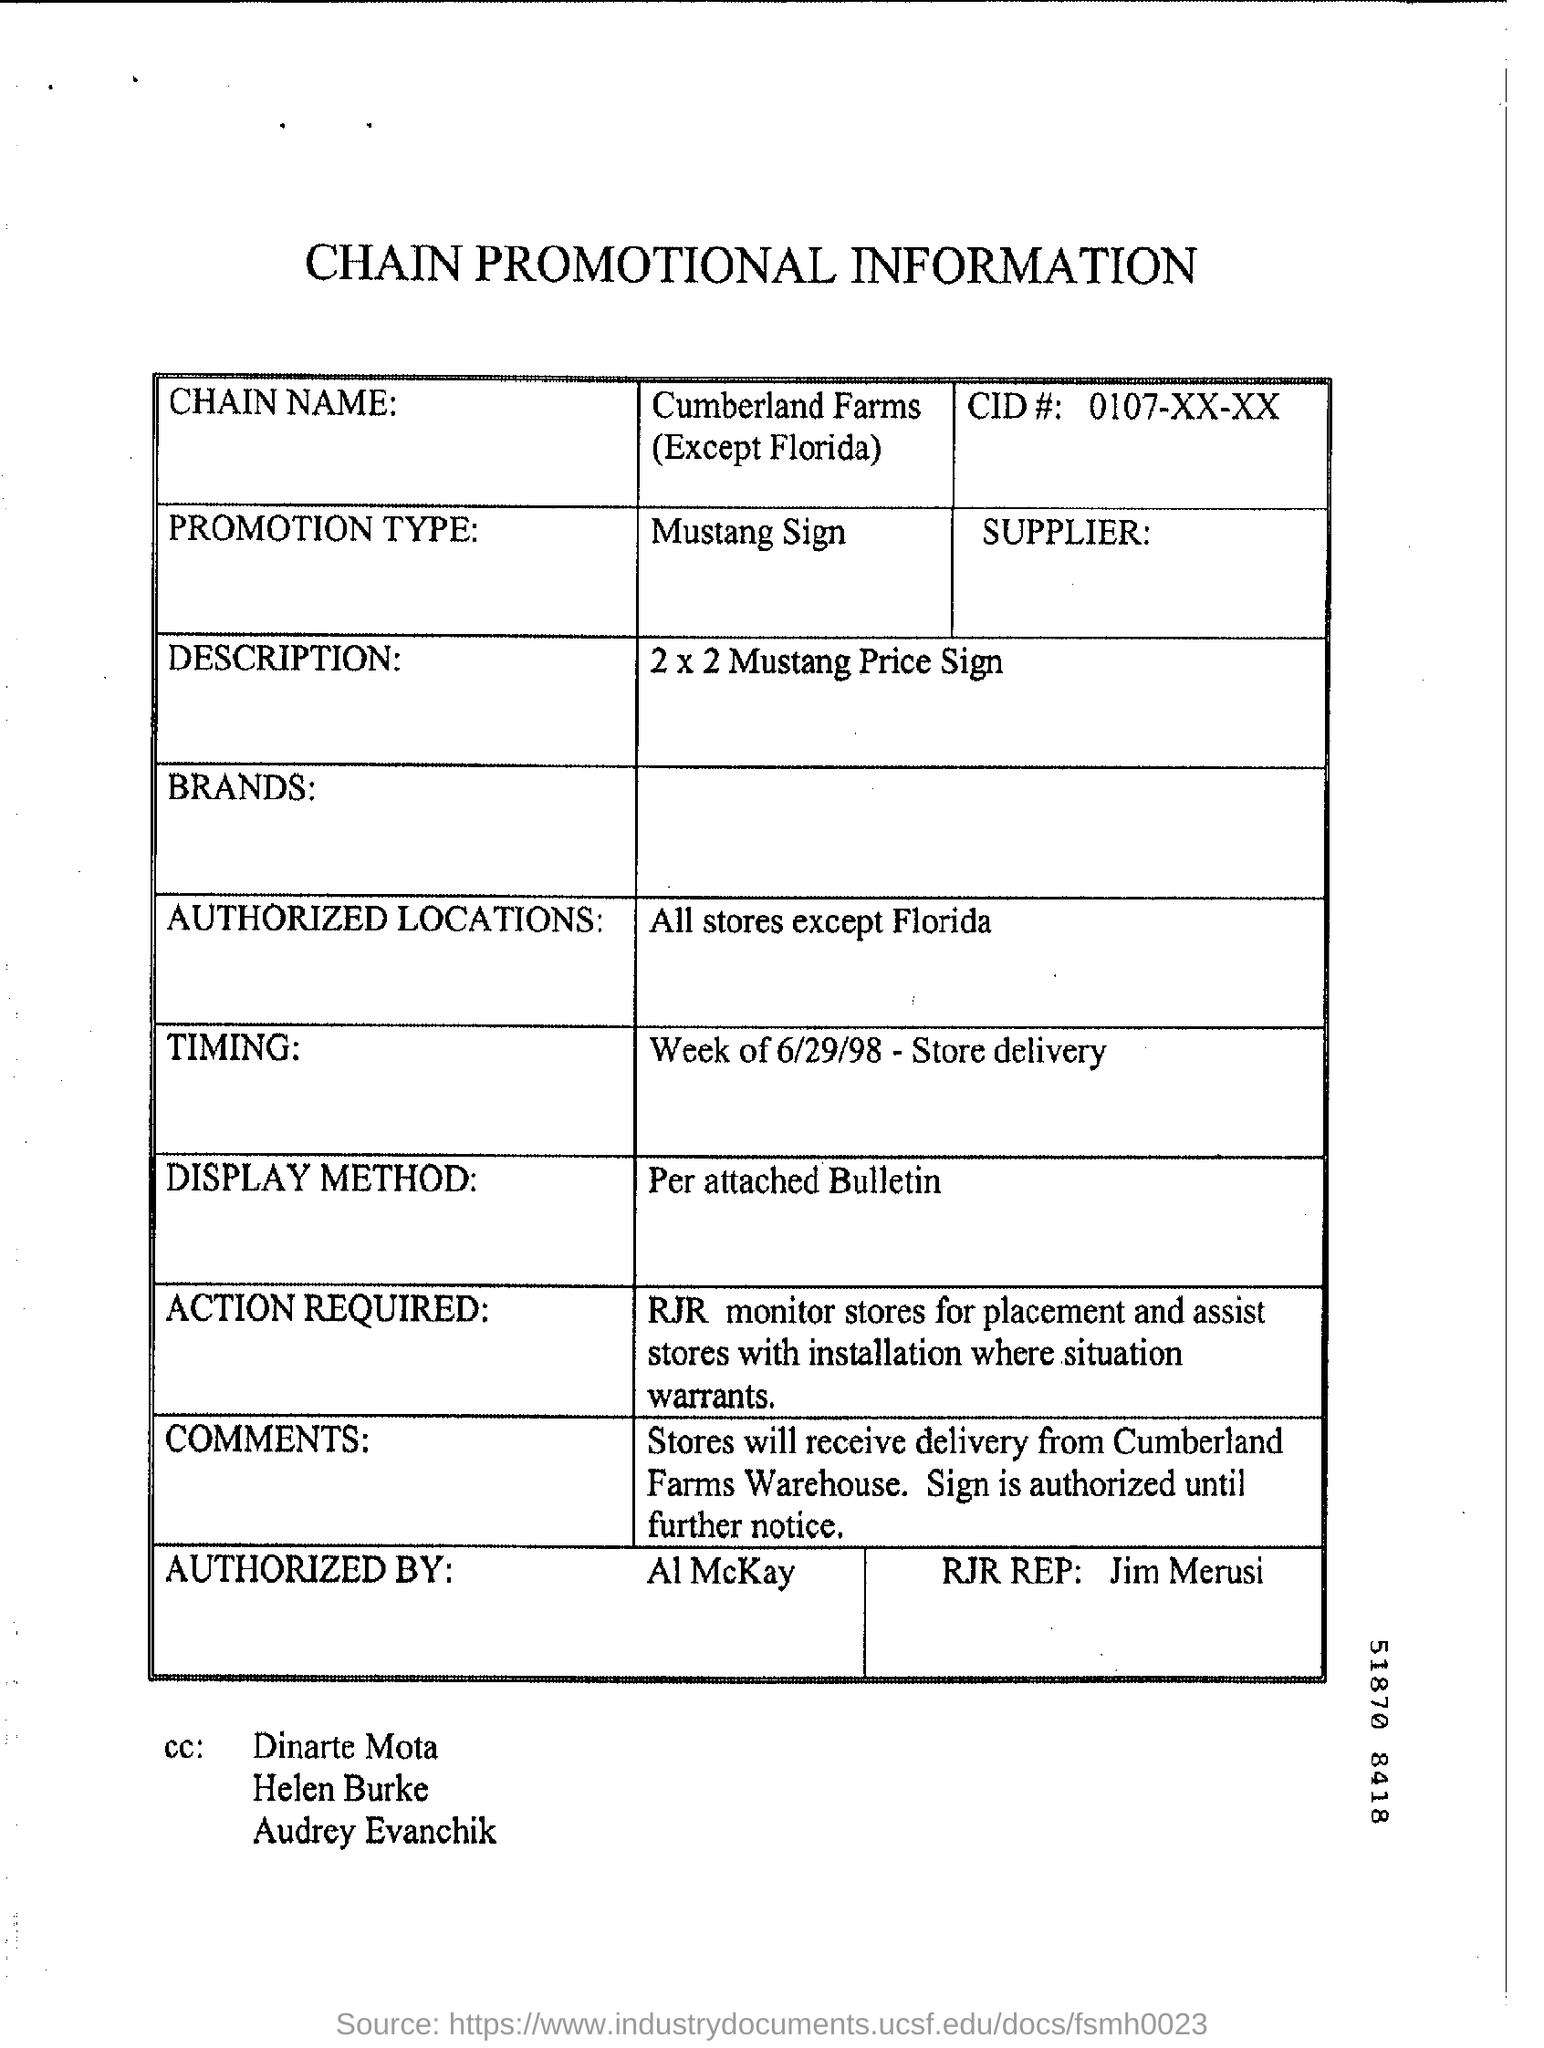What is the chain name?
Offer a very short reply. CUMBERLAND FARMS (EXCEPT FLORIDA). What is the CID#?
Give a very brief answer. 0107-XX-XX. What is the promotion type?
Make the answer very short. Mustang Sign. What is the description?
Keep it short and to the point. 2 x 2 Mustang Price Sign. What is the display method?
Your answer should be very brief. Per attached Bulletin. 